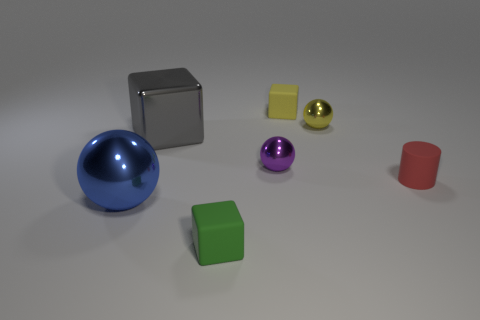Is there any other thing that has the same shape as the red matte thing?
Ensure brevity in your answer.  No. The tiny object in front of the ball on the left side of the big metal thing that is behind the small red object is what color?
Provide a succinct answer. Green. What number of shiny spheres are there?
Keep it short and to the point. 3. What number of large objects are green balls or blue metallic balls?
Provide a succinct answer. 1. What shape is the red object that is the same size as the yellow metal object?
Your answer should be compact. Cylinder. What is the small block to the left of the small cube behind the tiny yellow ball made of?
Your response must be concise. Rubber. Does the red cylinder have the same size as the yellow shiny thing?
Ensure brevity in your answer.  Yes. What number of things are metallic balls that are right of the blue shiny thing or big brown metallic cubes?
Provide a short and direct response. 2. What is the shape of the tiny rubber thing left of the small cube right of the small green matte block?
Give a very brief answer. Cube. Do the gray object and the rubber object in front of the large ball have the same size?
Give a very brief answer. No. 